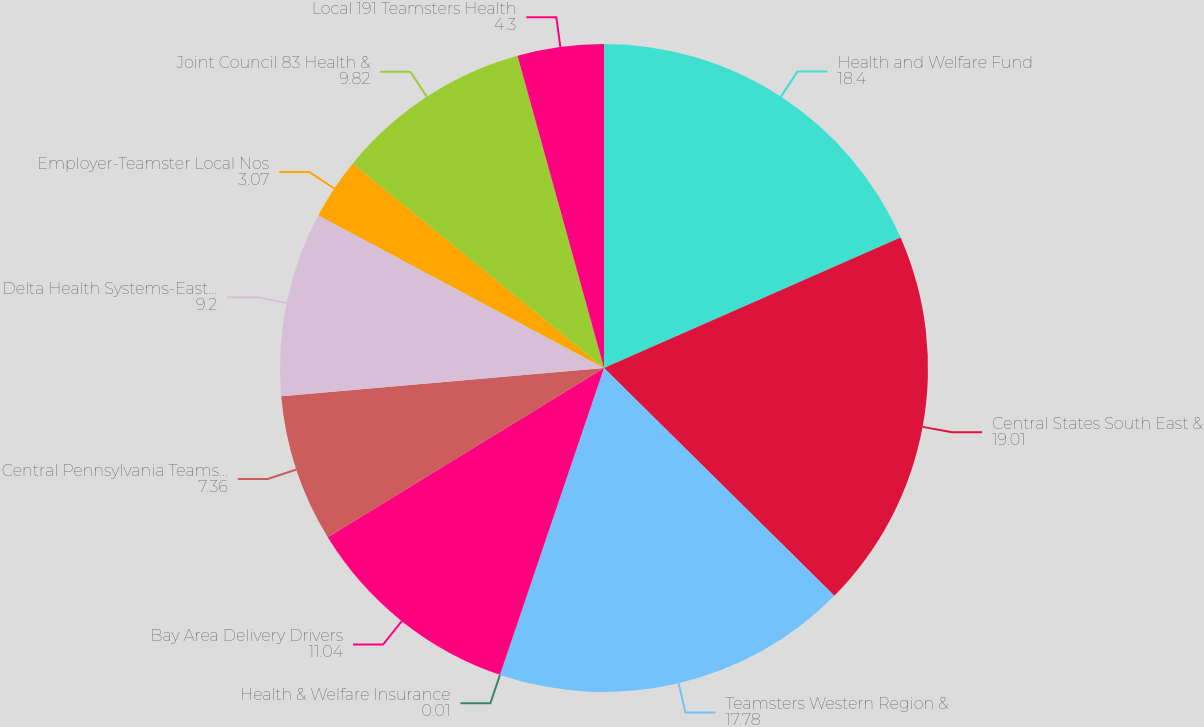<chart> <loc_0><loc_0><loc_500><loc_500><pie_chart><fcel>Health and Welfare Fund<fcel>Central States South East &<fcel>Teamsters Western Region &<fcel>Health & Welfare Insurance<fcel>Bay Area Delivery Drivers<fcel>Central Pennsylvania Teamsters<fcel>Delta Health Systems-East Bay<fcel>Employer-Teamster Local Nos<fcel>Joint Council 83 Health &<fcel>Local 191 Teamsters Health<nl><fcel>18.4%<fcel>19.01%<fcel>17.78%<fcel>0.01%<fcel>11.04%<fcel>7.36%<fcel>9.2%<fcel>3.07%<fcel>9.82%<fcel>4.3%<nl></chart> 